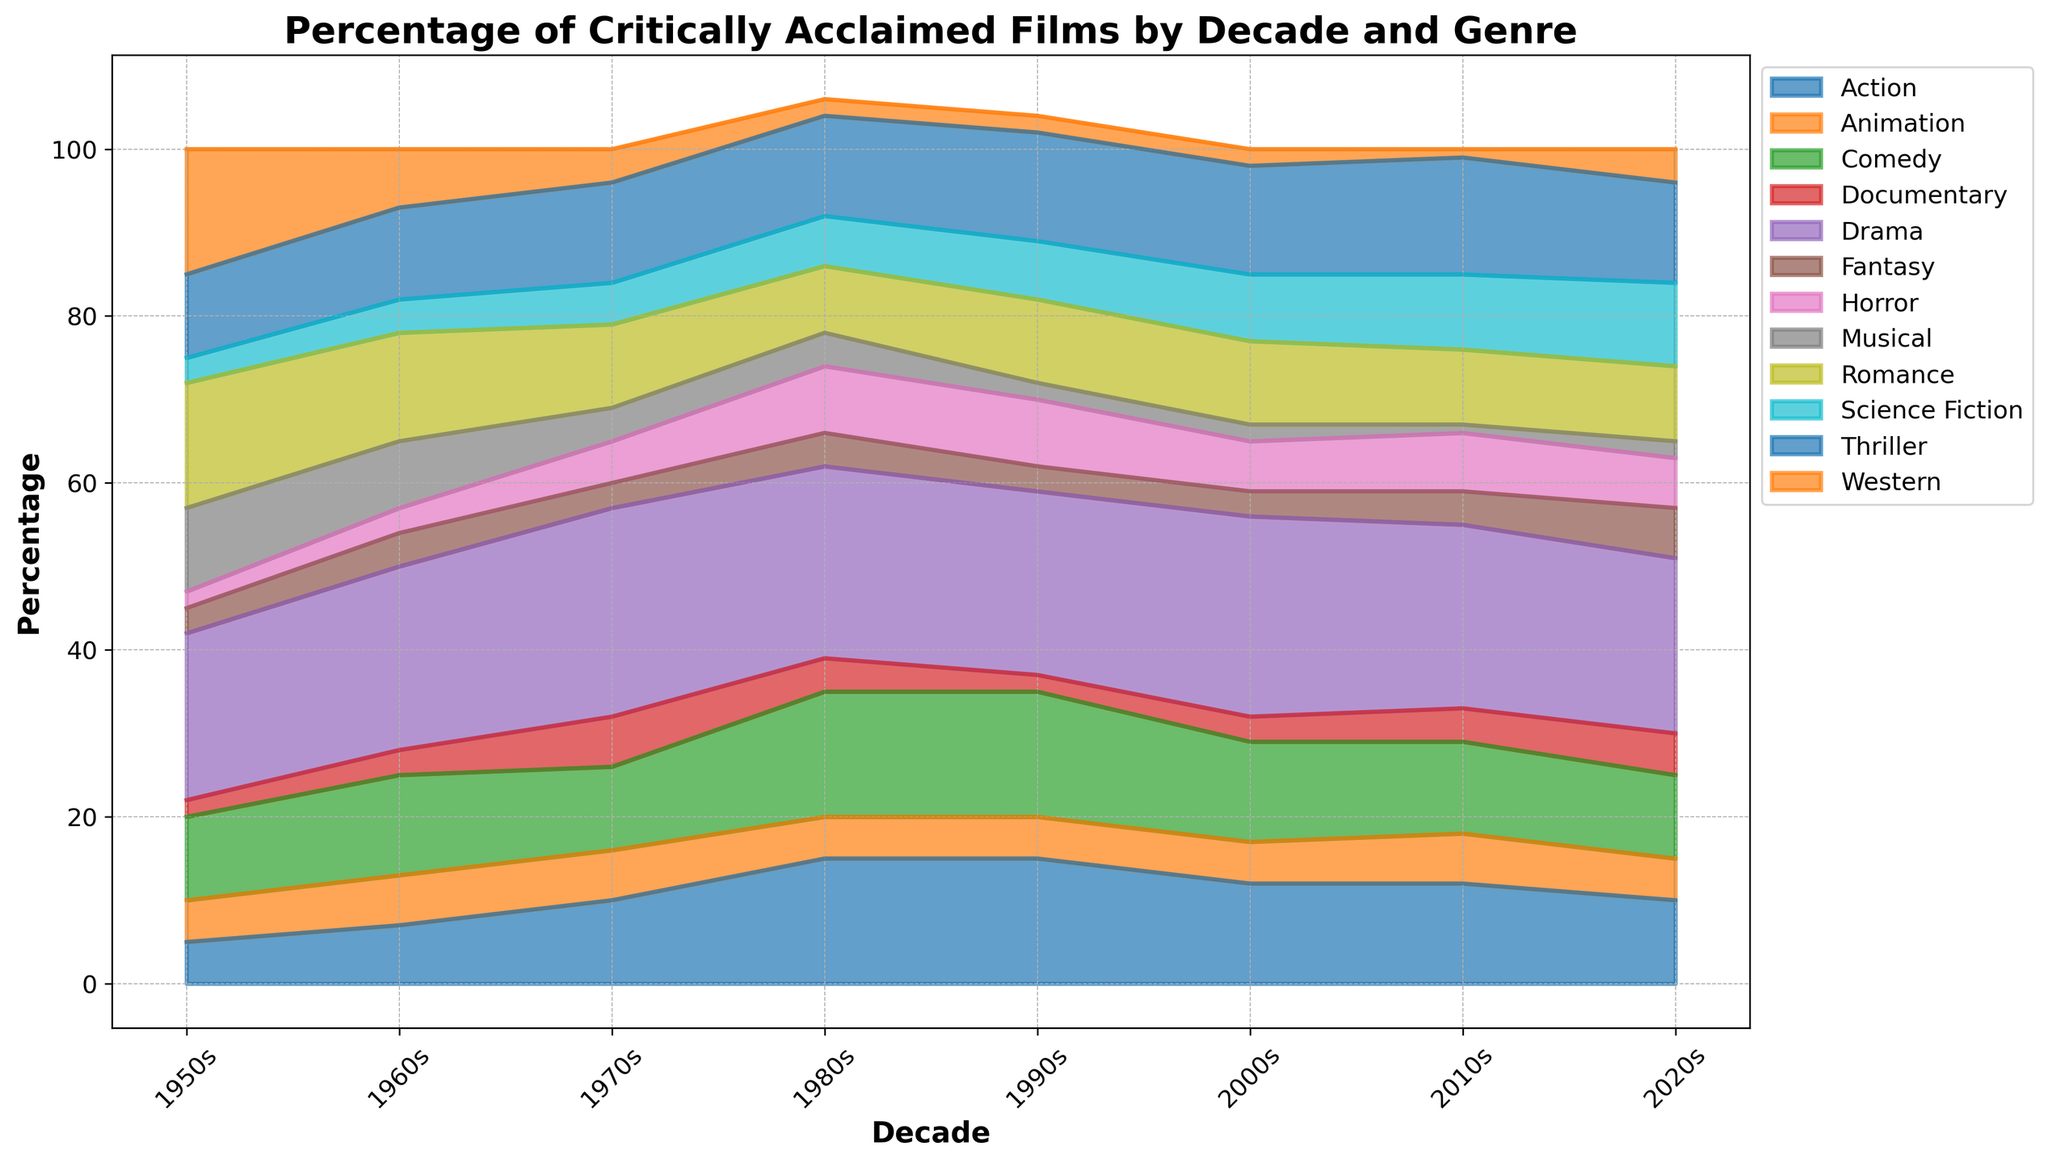What genre consistently had one of the highest percentages of critically acclaimed films across the decades? By visually scanning the area chart, we can observe that the Drama genre consistently shows a large and prominent area across all decades, indicating a high percentage of critically acclaimed films.
Answer: Drama How did the percentage of critically acclaimed Action films change from the 1950s to the 1980s? By comparing the area corresponding to Action films between the 1950s and the 1980s, we can see that the percentage increased from 5% in the 1950s to 15% in the 1980s.
Answer: Increased Which decade had the highest percentage of critically acclaimed Horror films? By examining the area attributed to Horror films, we can notice that the 1980s and 1990s stand out with 8% each, which is higher than in any other decade.
Answer: 1980s and 1990s In the 2000s, how did the combined percentage of critically acclaimed Romantic, Science Fiction, and Animation films compare to the percentage of critically acclaimed Drama films? First, sum the percentages of Romantic (10%), Science Fiction (8%), and Animation (5%) films, which equals 23%. The percentage for Drama films in the 2000s is 24%. Therefore, the combined percentage of Romantic, Science Fiction, and Animation films is slightly less than the Drama films percentage.
Answer: Slightly less What notable trend can be observed in the percentage of critically acclaimed Western films from the 1950s to the 2020s? By looking at the area corresponding to Western films, it is clear that there is a declining trend. Western films had a relatively high percentage in the 1950s (15%), but it dropped significantly over the decades, reaching just 2% or less in later decades before a slight rise to 4% in the 2020s.
Answer: Declining trend Which genre had the highest percentage increase from the 1950s to the 2010s? By comparing the areas of different genres between these decades, it is evident that the Action genre had the most significant percentage increase, rising from 5% in the 1950s to 12% in the 2010s.
Answer: Action During which decades did the percentages of critically acclaimed Thriller and Comedy films appear relatively steady? By looking at the areas for Thriller and Comedy films across all decades, we can observe that they appear relatively stable in the 1990s, 2000s, and 2010s with slight fluctuations. Thriller films range around 12-14%, and Comedy films range around 11-15%.
Answer: 1990s, 2000s, and 2010s What was the total percentage of critically acclaimed Documentary films in the 1970s and 1980s combined? Sum the Documentary film percentages for the 1970s (6%) and 1980s (4%), giving a total of 10%.
Answer: 10% Which decade shows the highest diversity in genres of critically acclaimed films, and how can you tell? The 1980s show a significant diversity in genres as many genres have relatively large and visible areas, and none of them dominate excessively. Multiple genres, such as Drama, Action, Comedy, Thriller, and Horror, all have substantial percentages.
Answer: 1980s How does the percentage of critically acclaimed Musical films in the 1960s compare to that in the 2020s? By examining the areas for Musical films, we can see that in the 1960s, the percentage was 8%, while in the 2020s, it decreased to 2%.
Answer: Decreased 